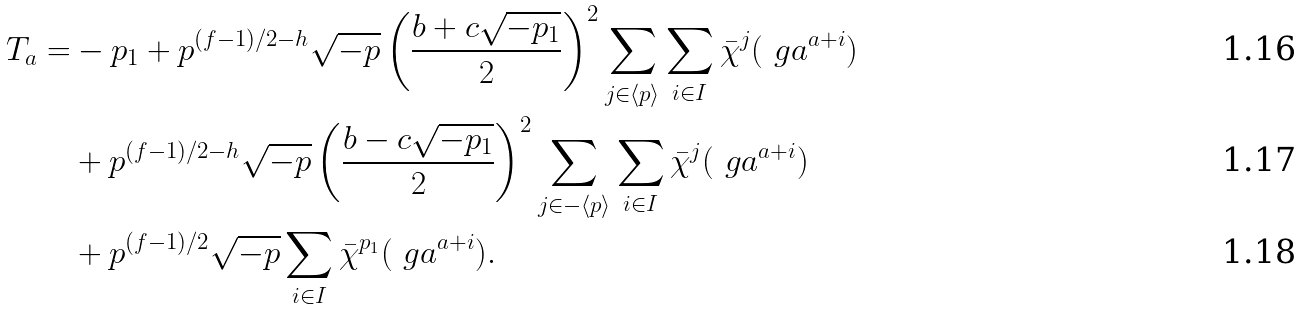<formula> <loc_0><loc_0><loc_500><loc_500>T _ { a } = & - p _ { 1 } + p ^ { ( f - 1 ) / 2 - h } \sqrt { - p } \left ( \frac { b + c \sqrt { - p _ { 1 } } } { 2 } \right ) ^ { 2 } \sum _ { j \in \langle p \rangle } \sum _ { i \in I } \bar { \chi } ^ { j } ( \ g a ^ { a + i } ) \\ & + p ^ { ( f - 1 ) / 2 - h } \sqrt { - p } \left ( \frac { b - c \sqrt { - p _ { 1 } } } { 2 } \right ) ^ { 2 } \sum _ { j \in - \langle p \rangle } \sum _ { i \in I } \bar { \chi } ^ { j } ( \ g a ^ { a + i } ) \\ & + p ^ { ( f - 1 ) / 2 } \sqrt { - p } \sum _ { i \in I } \bar { \chi } ^ { p _ { 1 } } ( \ g a ^ { a + i } ) .</formula> 